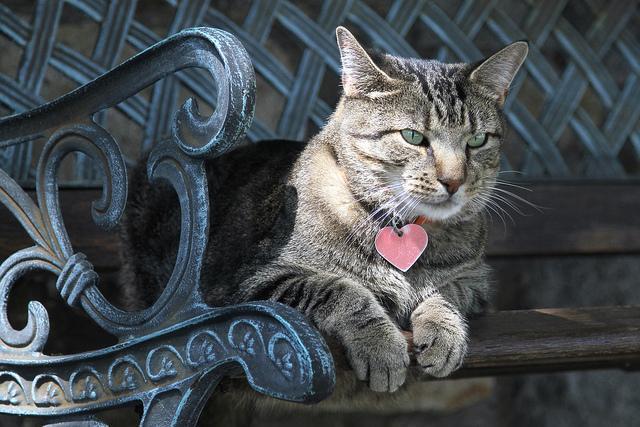How many benches are there?
Give a very brief answer. 2. How many birds are in the sky?
Give a very brief answer. 0. 